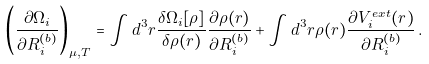Convert formula to latex. <formula><loc_0><loc_0><loc_500><loc_500>\left ( \frac { \partial \Omega _ { i } } { \partial R _ { i } ^ { ( b ) } } \right ) _ { \mu , T } = \int d ^ { 3 } r \frac { \delta \Omega _ { i } [ \rho ] } { \delta \rho ( { r } ) } \frac { \partial \rho ( { r } ) } { \partial R _ { i } ^ { ( b ) } } + \int d ^ { 3 } r \rho ( { r } ) \frac { \partial V _ { i } ^ { e x t } ( { r } ) } { \partial R _ { i } ^ { ( b ) } } \, .</formula> 